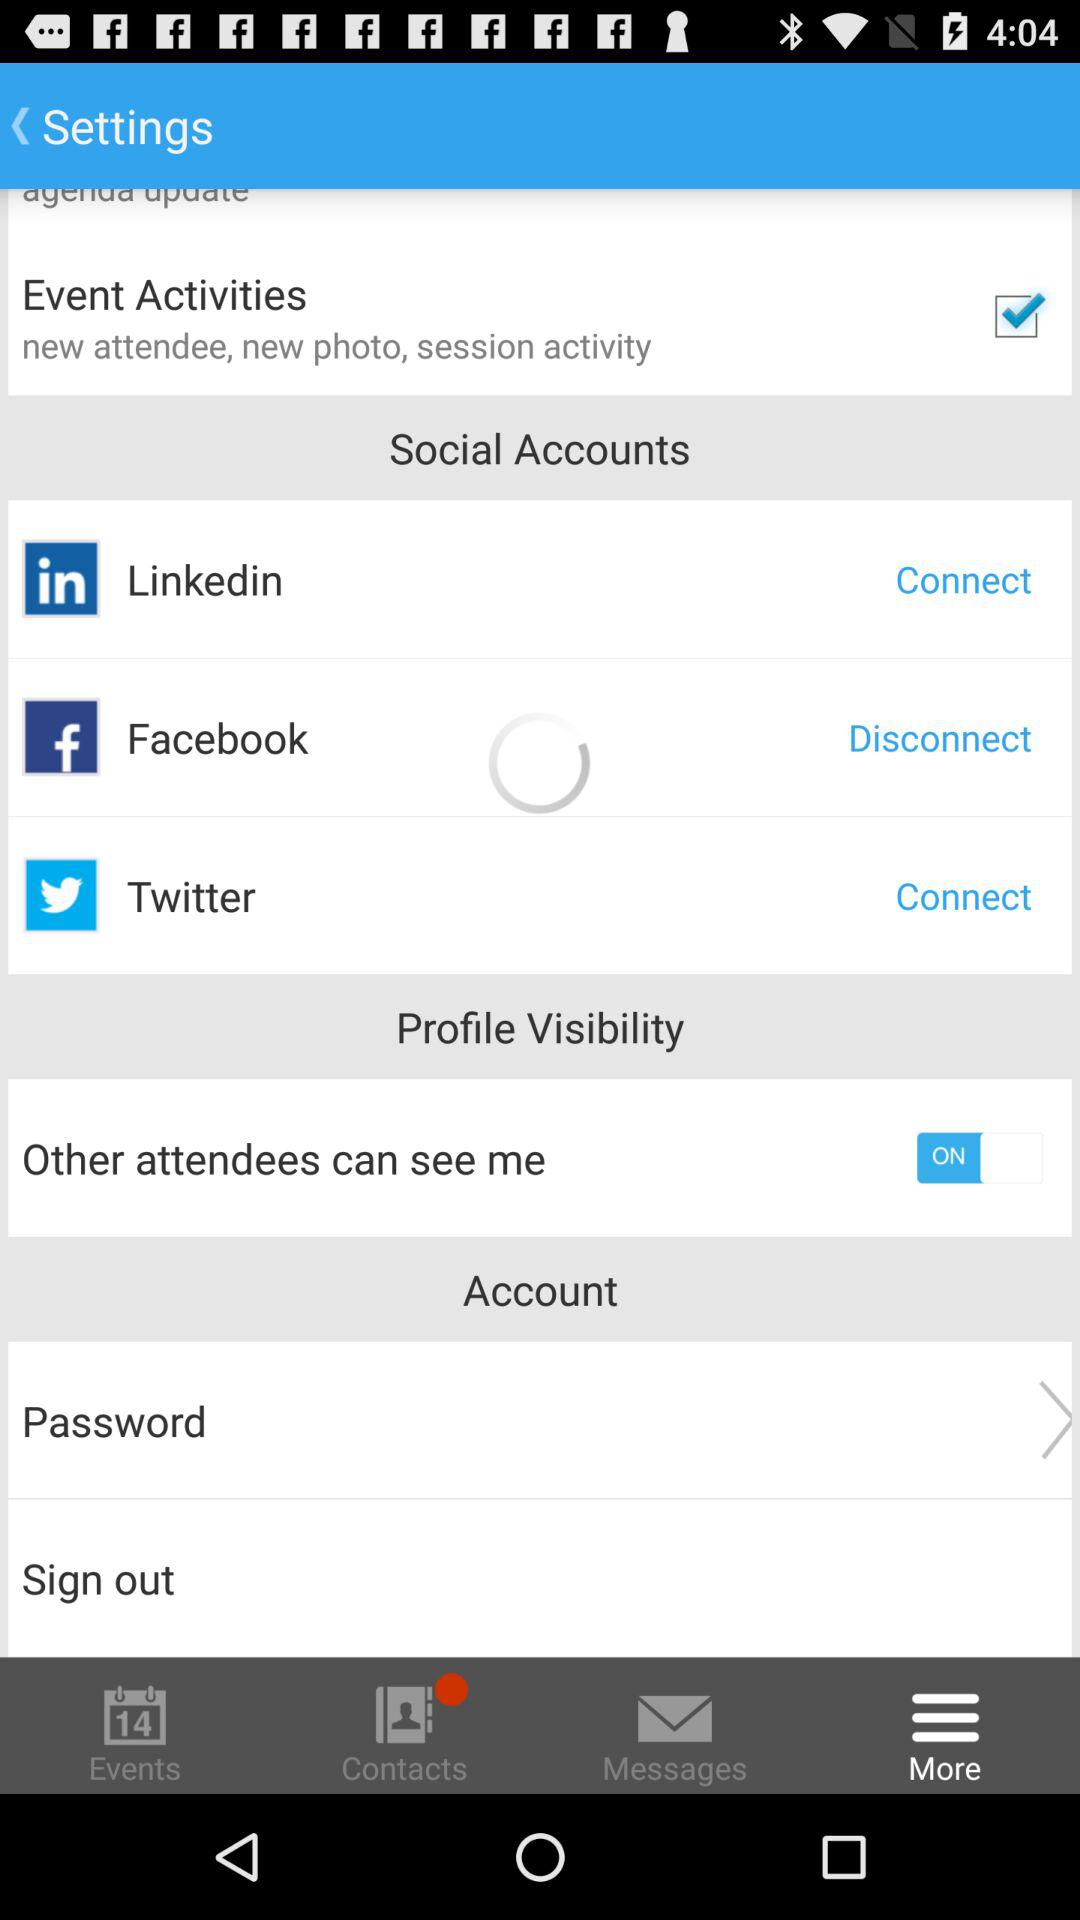What are the options in "Social Accounts"? The options in "Social Accounts" are "Linkedin", "Facebook" and "Twitter". 